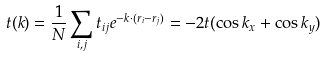Convert formula to latex. <formula><loc_0><loc_0><loc_500><loc_500>t ( k ) = \frac { 1 } { N } \sum _ { i , j } t _ { i j } e ^ { - k \cdot ( r _ { i } - r _ { j } ) } = - 2 t ( \cos { k _ { x } } + \cos { k _ { y } } )</formula> 